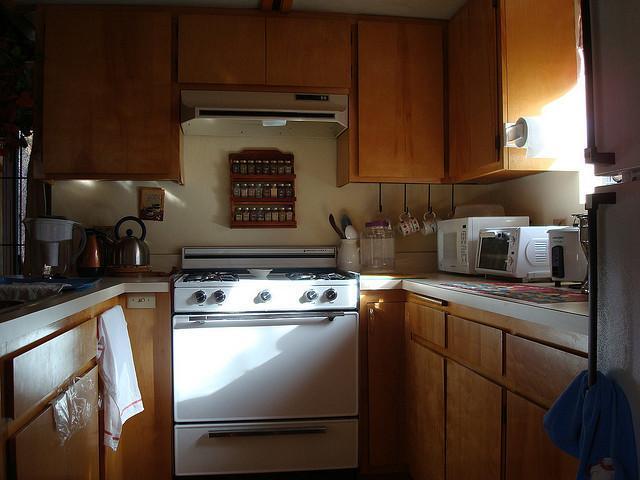How many ovens are there?
Give a very brief answer. 2. 